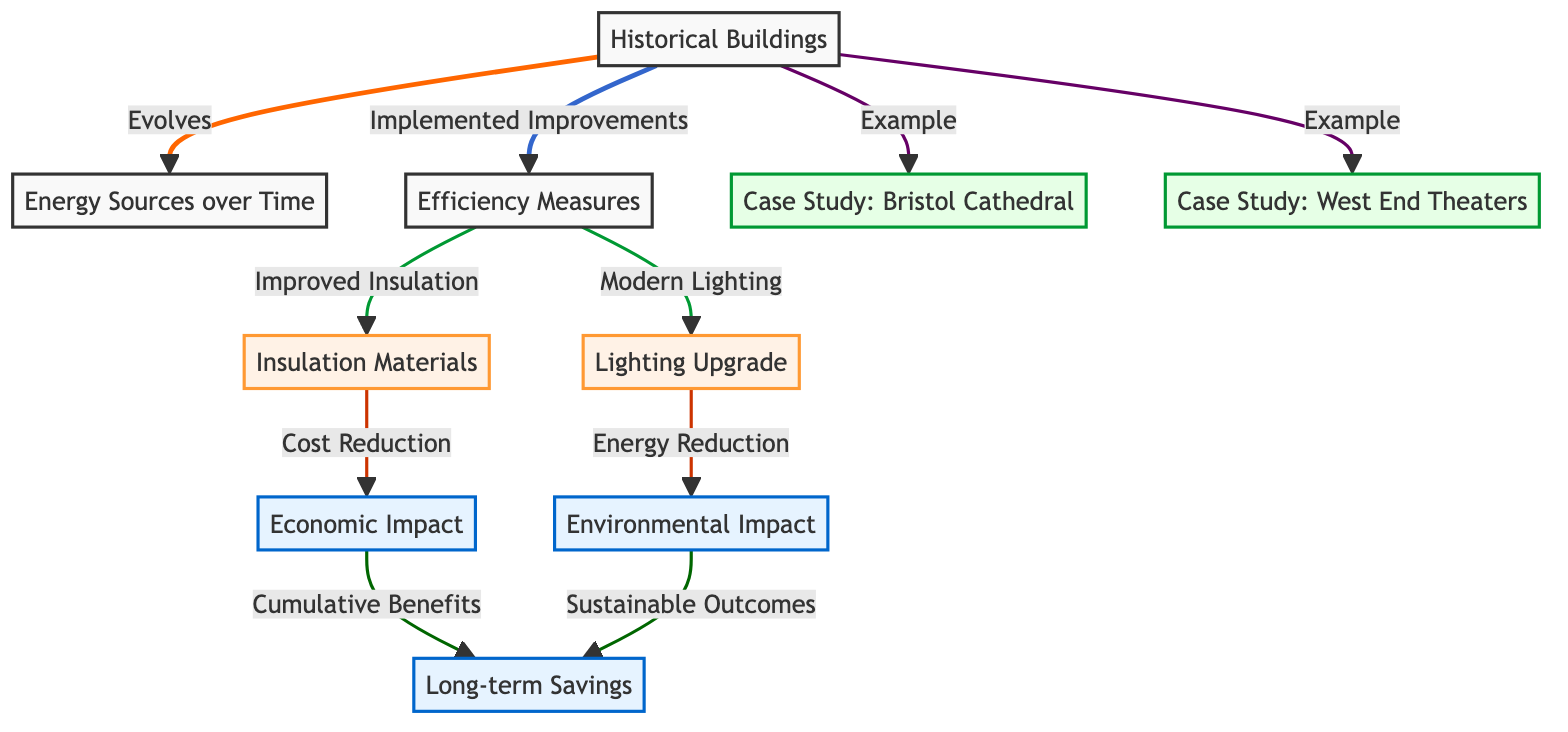What do Historical Buildings evolve into over time? The diagram shows an arrow connecting Historical Buildings to Energy Sources over Time, indicating that Historical Buildings evolve into Energy Sources as they are updated and improved.
Answer: Energy Sources over Time What are two examples provided for Historical Buildings in the diagram? The diagram lists two case studies under Historical Buildings: Bristol Cathedral and West End Theaters. These are the examples mentioned for the discussion on historical infrastructure.
Answer: Bristol Cathedral, West End Theaters What are the two efficiency measures implemented according to the diagram? The diagram connects Historical Buildings to two specific efficiency measures: Improved Insulation and Modern Lighting, indicating these are measures taken to enhance energy efficiency.
Answer: Improved Insulation, Modern Lighting Which impact is related to cost reduction? The diagram connects Improved Insulation to Economic Impact, indicating that improved insulation leads to cost reduction. Therefore, the impact associated with this measure is Economic Impact.
Answer: Economic Impact What are the long-term outcomes described in the diagram? The diagram indicates that both Economic Impact and Environmental Impact lead to Long-term Savings. Thus, the long-term outcomes described are cumulative benefits from cost reduction and sustainable outcomes.
Answer: Long-term Savings Which two measures are shown to have environmental implications? The diagram shows arrows from Modern Lighting and Improved Insulation leading to Environmental Impact and associates them with energy reduction and sustainable outcomes, indicating that both measures positively impact the environment.
Answer: Modern Lighting, Improved Insulation What cumulative benefit is connected to Economic Impact and Environmental Impact? The diagram points to Long-term Savings as the outcome from both Economic Impact and Environmental Impact, demonstrating the cumulative benefits achieved through energy efficiency improvements.
Answer: Long-term Savings 